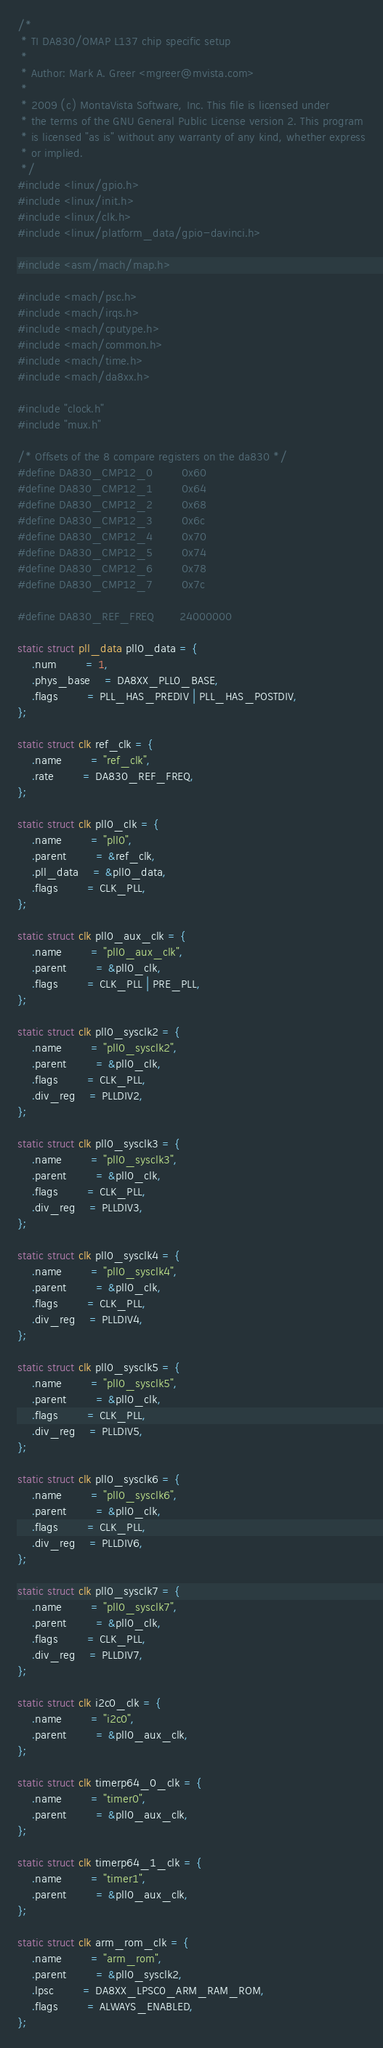Convert code to text. <code><loc_0><loc_0><loc_500><loc_500><_C_>/*
 * TI DA830/OMAP L137 chip specific setup
 *
 * Author: Mark A. Greer <mgreer@mvista.com>
 *
 * 2009 (c) MontaVista Software, Inc. This file is licensed under
 * the terms of the GNU General Public License version 2. This program
 * is licensed "as is" without any warranty of any kind, whether express
 * or implied.
 */
#include <linux/gpio.h>
#include <linux/init.h>
#include <linux/clk.h>
#include <linux/platform_data/gpio-davinci.h>

#include <asm/mach/map.h>

#include <mach/psc.h>
#include <mach/irqs.h>
#include <mach/cputype.h>
#include <mach/common.h>
#include <mach/time.h>
#include <mach/da8xx.h>

#include "clock.h"
#include "mux.h"

/* Offsets of the 8 compare registers on the da830 */
#define DA830_CMP12_0		0x60
#define DA830_CMP12_1		0x64
#define DA830_CMP12_2		0x68
#define DA830_CMP12_3		0x6c
#define DA830_CMP12_4		0x70
#define DA830_CMP12_5		0x74
#define DA830_CMP12_6		0x78
#define DA830_CMP12_7		0x7c

#define DA830_REF_FREQ		24000000

static struct pll_data pll0_data = {
	.num		= 1,
	.phys_base	= DA8XX_PLL0_BASE,
	.flags		= PLL_HAS_PREDIV | PLL_HAS_POSTDIV,
};

static struct clk ref_clk = {
	.name		= "ref_clk",
	.rate		= DA830_REF_FREQ,
};

static struct clk pll0_clk = {
	.name		= "pll0",
	.parent		= &ref_clk,
	.pll_data	= &pll0_data,
	.flags		= CLK_PLL,
};

static struct clk pll0_aux_clk = {
	.name		= "pll0_aux_clk",
	.parent		= &pll0_clk,
	.flags		= CLK_PLL | PRE_PLL,
};

static struct clk pll0_sysclk2 = {
	.name		= "pll0_sysclk2",
	.parent		= &pll0_clk,
	.flags		= CLK_PLL,
	.div_reg	= PLLDIV2,
};

static struct clk pll0_sysclk3 = {
	.name		= "pll0_sysclk3",
	.parent		= &pll0_clk,
	.flags		= CLK_PLL,
	.div_reg	= PLLDIV3,
};

static struct clk pll0_sysclk4 = {
	.name		= "pll0_sysclk4",
	.parent		= &pll0_clk,
	.flags		= CLK_PLL,
	.div_reg	= PLLDIV4,
};

static struct clk pll0_sysclk5 = {
	.name		= "pll0_sysclk5",
	.parent		= &pll0_clk,
	.flags		= CLK_PLL,
	.div_reg	= PLLDIV5,
};

static struct clk pll0_sysclk6 = {
	.name		= "pll0_sysclk6",
	.parent		= &pll0_clk,
	.flags		= CLK_PLL,
	.div_reg	= PLLDIV6,
};

static struct clk pll0_sysclk7 = {
	.name		= "pll0_sysclk7",
	.parent		= &pll0_clk,
	.flags		= CLK_PLL,
	.div_reg	= PLLDIV7,
};

static struct clk i2c0_clk = {
	.name		= "i2c0",
	.parent		= &pll0_aux_clk,
};

static struct clk timerp64_0_clk = {
	.name		= "timer0",
	.parent		= &pll0_aux_clk,
};

static struct clk timerp64_1_clk = {
	.name		= "timer1",
	.parent		= &pll0_aux_clk,
};

static struct clk arm_rom_clk = {
	.name		= "arm_rom",
	.parent		= &pll0_sysclk2,
	.lpsc		= DA8XX_LPSC0_ARM_RAM_ROM,
	.flags		= ALWAYS_ENABLED,
};
</code> 